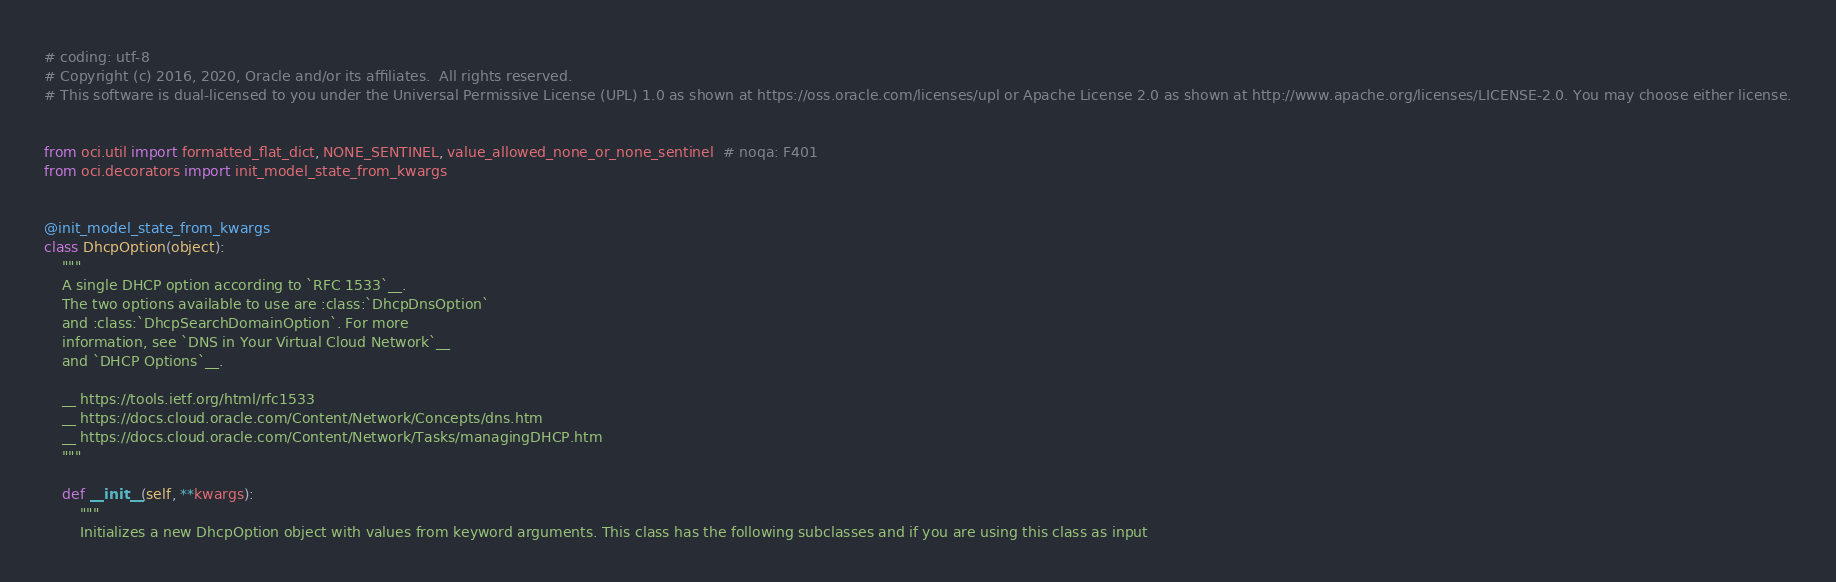Convert code to text. <code><loc_0><loc_0><loc_500><loc_500><_Python_># coding: utf-8
# Copyright (c) 2016, 2020, Oracle and/or its affiliates.  All rights reserved.
# This software is dual-licensed to you under the Universal Permissive License (UPL) 1.0 as shown at https://oss.oracle.com/licenses/upl or Apache License 2.0 as shown at http://www.apache.org/licenses/LICENSE-2.0. You may choose either license.


from oci.util import formatted_flat_dict, NONE_SENTINEL, value_allowed_none_or_none_sentinel  # noqa: F401
from oci.decorators import init_model_state_from_kwargs


@init_model_state_from_kwargs
class DhcpOption(object):
    """
    A single DHCP option according to `RFC 1533`__.
    The two options available to use are :class:`DhcpDnsOption`
    and :class:`DhcpSearchDomainOption`. For more
    information, see `DNS in Your Virtual Cloud Network`__
    and `DHCP Options`__.

    __ https://tools.ietf.org/html/rfc1533
    __ https://docs.cloud.oracle.com/Content/Network/Concepts/dns.htm
    __ https://docs.cloud.oracle.com/Content/Network/Tasks/managingDHCP.htm
    """

    def __init__(self, **kwargs):
        """
        Initializes a new DhcpOption object with values from keyword arguments. This class has the following subclasses and if you are using this class as input</code> 